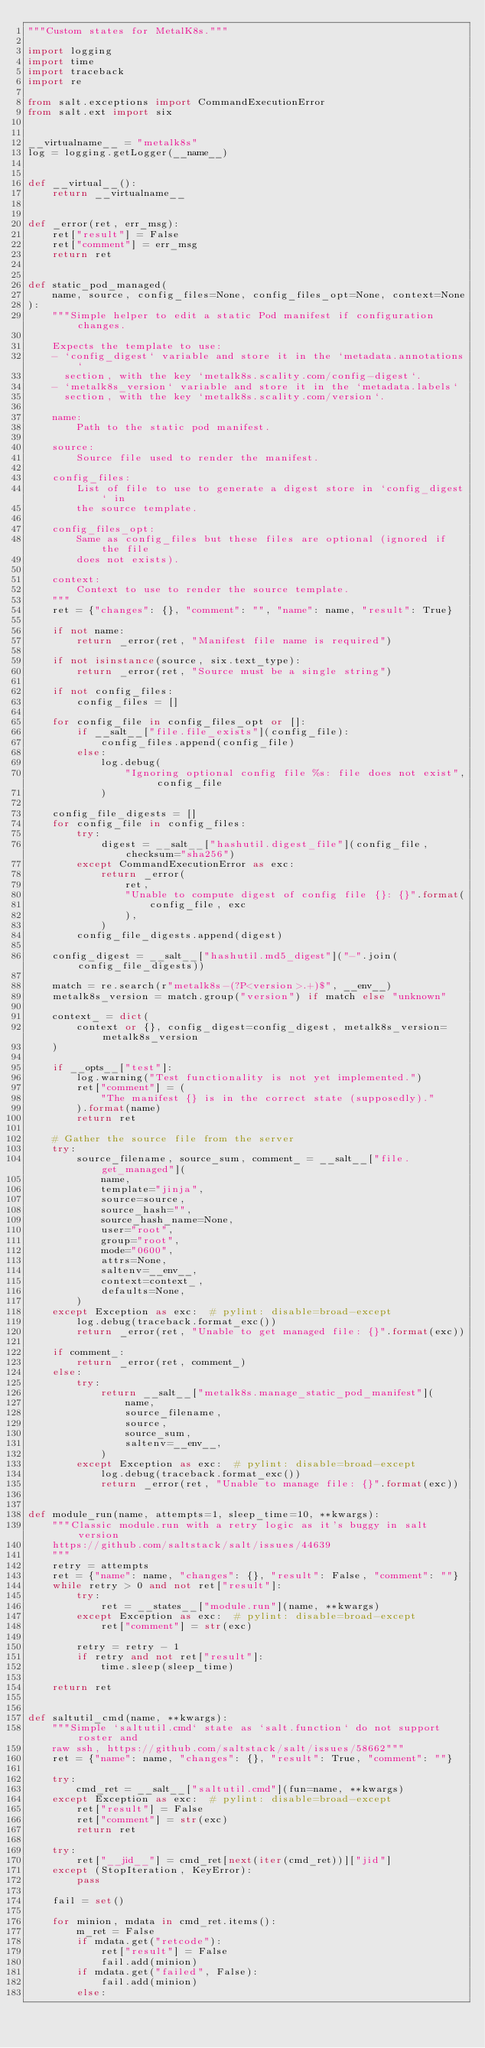Convert code to text. <code><loc_0><loc_0><loc_500><loc_500><_Python_>"""Custom states for MetalK8s."""

import logging
import time
import traceback
import re

from salt.exceptions import CommandExecutionError
from salt.ext import six


__virtualname__ = "metalk8s"
log = logging.getLogger(__name__)


def __virtual__():
    return __virtualname__


def _error(ret, err_msg):
    ret["result"] = False
    ret["comment"] = err_msg
    return ret


def static_pod_managed(
    name, source, config_files=None, config_files_opt=None, context=None
):
    """Simple helper to edit a static Pod manifest if configuration changes.

    Expects the template to use:
    - `config_digest` variable and store it in the `metadata.annotations`
      section, with the key `metalk8s.scality.com/config-digest`.
    - `metalk8s_version` variable and store it in the `metadata.labels`
      section, with the key `metalk8s.scality.com/version`.

    name:
        Path to the static pod manifest.

    source:
        Source file used to render the manifest.

    config_files:
        List of file to use to generate a digest store in `config_digest` in
        the source template.

    config_files_opt:
        Same as config_files but these files are optional (ignored if the file
        does not exists).

    context:
        Context to use to render the source template.
    """
    ret = {"changes": {}, "comment": "", "name": name, "result": True}

    if not name:
        return _error(ret, "Manifest file name is required")

    if not isinstance(source, six.text_type):
        return _error(ret, "Source must be a single string")

    if not config_files:
        config_files = []

    for config_file in config_files_opt or []:
        if __salt__["file.file_exists"](config_file):
            config_files.append(config_file)
        else:
            log.debug(
                "Ignoring optional config file %s: file does not exist", config_file
            )

    config_file_digests = []
    for config_file in config_files:
        try:
            digest = __salt__["hashutil.digest_file"](config_file, checksum="sha256")
        except CommandExecutionError as exc:
            return _error(
                ret,
                "Unable to compute digest of config file {}: {}".format(
                    config_file, exc
                ),
            )
        config_file_digests.append(digest)

    config_digest = __salt__["hashutil.md5_digest"]("-".join(config_file_digests))

    match = re.search(r"metalk8s-(?P<version>.+)$", __env__)
    metalk8s_version = match.group("version") if match else "unknown"

    context_ = dict(
        context or {}, config_digest=config_digest, metalk8s_version=metalk8s_version
    )

    if __opts__["test"]:
        log.warning("Test functionality is not yet implemented.")
        ret["comment"] = (
            "The manifest {} is in the correct state (supposedly)."
        ).format(name)
        return ret

    # Gather the source file from the server
    try:
        source_filename, source_sum, comment_ = __salt__["file.get_managed"](
            name,
            template="jinja",
            source=source,
            source_hash="",
            source_hash_name=None,
            user="root",
            group="root",
            mode="0600",
            attrs=None,
            saltenv=__env__,
            context=context_,
            defaults=None,
        )
    except Exception as exc:  # pylint: disable=broad-except
        log.debug(traceback.format_exc())
        return _error(ret, "Unable to get managed file: {}".format(exc))

    if comment_:
        return _error(ret, comment_)
    else:
        try:
            return __salt__["metalk8s.manage_static_pod_manifest"](
                name,
                source_filename,
                source,
                source_sum,
                saltenv=__env__,
            )
        except Exception as exc:  # pylint: disable=broad-except
            log.debug(traceback.format_exc())
            return _error(ret, "Unable to manage file: {}".format(exc))


def module_run(name, attempts=1, sleep_time=10, **kwargs):
    """Classic module.run with a retry logic as it's buggy in salt version
    https://github.com/saltstack/salt/issues/44639
    """
    retry = attempts
    ret = {"name": name, "changes": {}, "result": False, "comment": ""}
    while retry > 0 and not ret["result"]:
        try:
            ret = __states__["module.run"](name, **kwargs)
        except Exception as exc:  # pylint: disable=broad-except
            ret["comment"] = str(exc)

        retry = retry - 1
        if retry and not ret["result"]:
            time.sleep(sleep_time)

    return ret


def saltutil_cmd(name, **kwargs):
    """Simple `saltutil.cmd` state as `salt.function` do not support roster and
    raw ssh, https://github.com/saltstack/salt/issues/58662"""
    ret = {"name": name, "changes": {}, "result": True, "comment": ""}

    try:
        cmd_ret = __salt__["saltutil.cmd"](fun=name, **kwargs)
    except Exception as exc:  # pylint: disable=broad-except
        ret["result"] = False
        ret["comment"] = str(exc)
        return ret

    try:
        ret["__jid__"] = cmd_ret[next(iter(cmd_ret))]["jid"]
    except (StopIteration, KeyError):
        pass

    fail = set()

    for minion, mdata in cmd_ret.items():
        m_ret = False
        if mdata.get("retcode"):
            ret["result"] = False
            fail.add(minion)
        if mdata.get("failed", False):
            fail.add(minion)
        else:</code> 